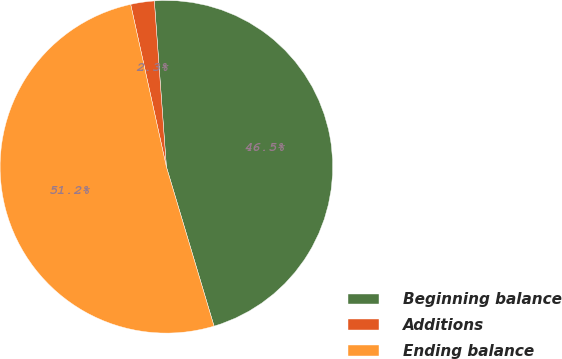Convert chart. <chart><loc_0><loc_0><loc_500><loc_500><pie_chart><fcel>Beginning balance<fcel>Additions<fcel>Ending balance<nl><fcel>46.53%<fcel>2.29%<fcel>51.18%<nl></chart> 